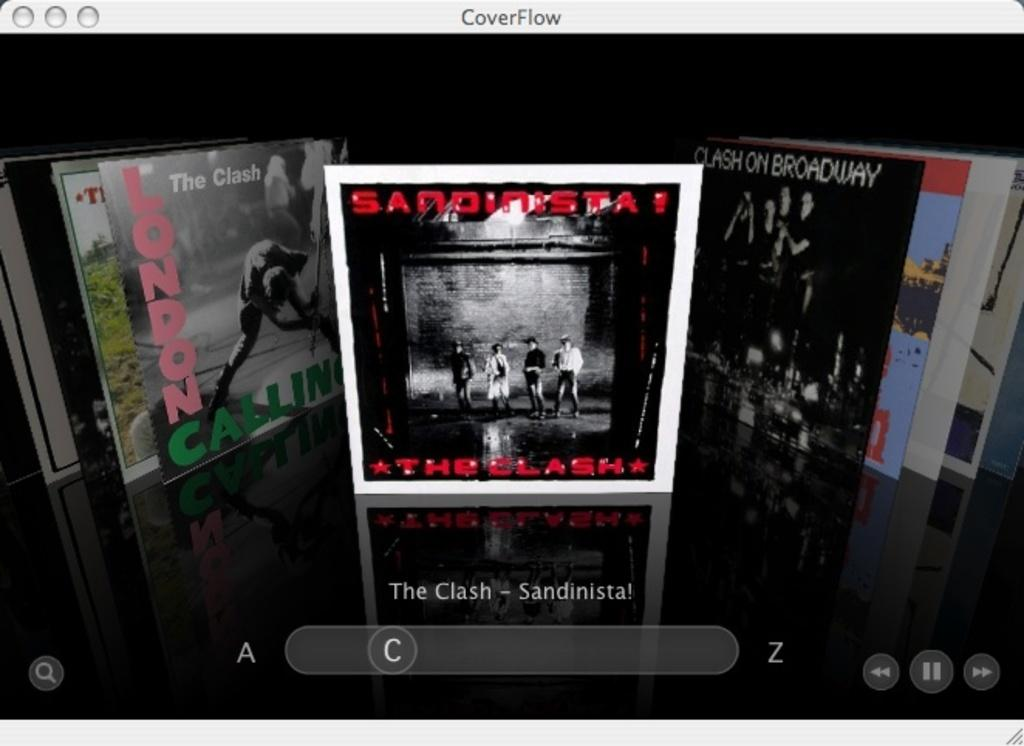<image>
Create a compact narrative representing the image presented. An album by The Clash is shown among several other albums. 